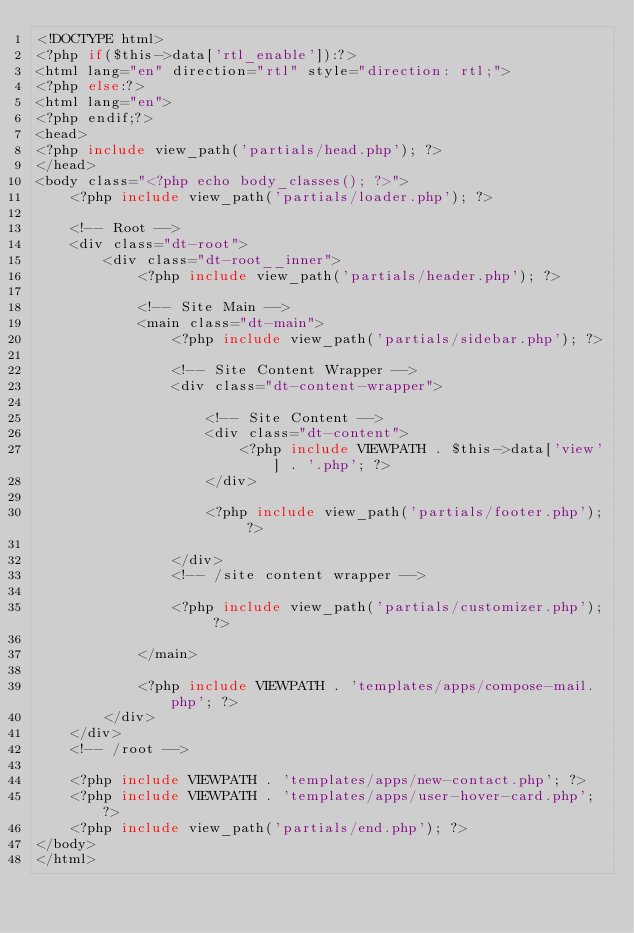Convert code to text. <code><loc_0><loc_0><loc_500><loc_500><_PHP_><!DOCTYPE html>
<?php if($this->data['rtl_enable']):?>
<html lang="en" direction="rtl" style="direction: rtl;">
<?php else:?>
<html lang="en">
<?php endif;?>
<head>
<?php include view_path('partials/head.php'); ?>
</head>
<body class="<?php echo body_classes(); ?>">
    <?php include view_path('partials/loader.php'); ?>

    <!-- Root -->
    <div class="dt-root">
        <div class="dt-root__inner">
            <?php include view_path('partials/header.php'); ?>

            <!-- Site Main -->
            <main class="dt-main">
                <?php include view_path('partials/sidebar.php'); ?>

                <!-- Site Content Wrapper -->
                <div class="dt-content-wrapper">

                    <!-- Site Content -->
                    <div class="dt-content">
                        <?php include VIEWPATH . $this->data['view'] . '.php'; ?>
                    </div>

                    <?php include view_path('partials/footer.php'); ?>

                </div>
                <!-- /site content wrapper -->

                <?php include view_path('partials/customizer.php'); ?>

            </main>
            
            <?php include VIEWPATH . 'templates/apps/compose-mail.php'; ?>
        </div>
    </div>
    <!-- /root -->

    <?php include VIEWPATH . 'templates/apps/new-contact.php'; ?>
    <?php include VIEWPATH . 'templates/apps/user-hover-card.php'; ?>
    <?php include view_path('partials/end.php'); ?>
</body>
</html></code> 